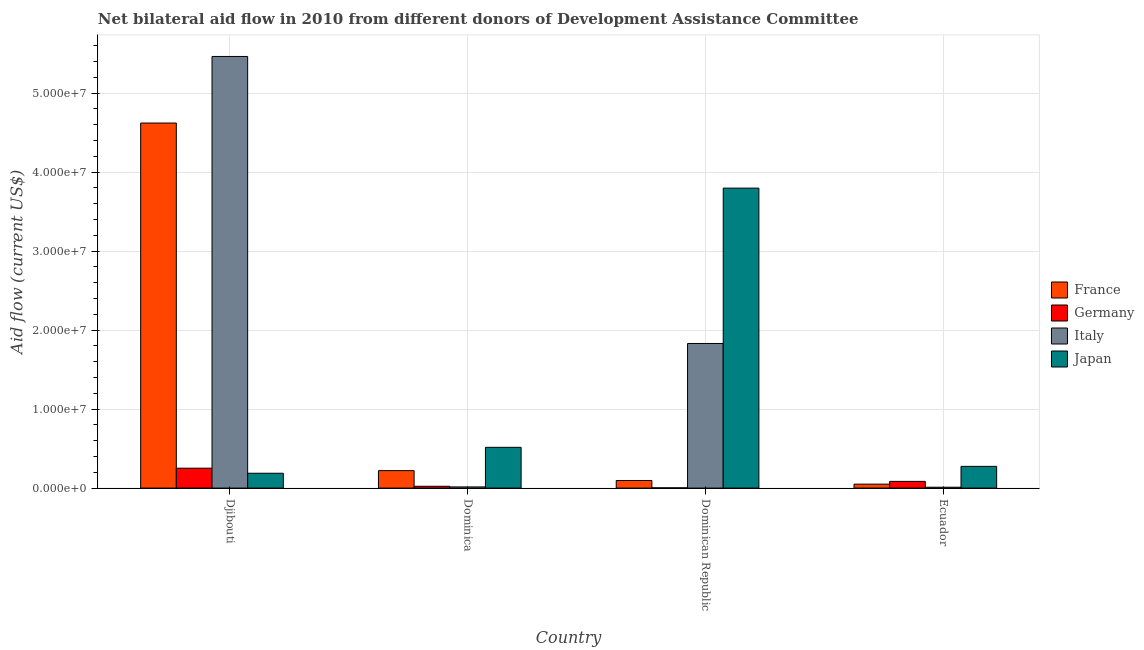Are the number of bars on each tick of the X-axis equal?
Your answer should be very brief. Yes. What is the label of the 4th group of bars from the left?
Ensure brevity in your answer.  Ecuador. What is the amount of aid given by france in Djibouti?
Your answer should be very brief. 4.62e+07. Across all countries, what is the maximum amount of aid given by japan?
Your answer should be compact. 3.80e+07. Across all countries, what is the minimum amount of aid given by france?
Provide a succinct answer. 5.00e+05. In which country was the amount of aid given by france maximum?
Provide a short and direct response. Djibouti. In which country was the amount of aid given by france minimum?
Keep it short and to the point. Ecuador. What is the total amount of aid given by japan in the graph?
Provide a succinct answer. 4.78e+07. What is the difference between the amount of aid given by france in Dominica and that in Ecuador?
Provide a succinct answer. 1.71e+06. What is the difference between the amount of aid given by germany in Ecuador and the amount of aid given by italy in Dominican Republic?
Keep it short and to the point. -1.75e+07. What is the average amount of aid given by germany per country?
Give a very brief answer. 9.08e+05. What is the difference between the amount of aid given by germany and amount of aid given by france in Djibouti?
Offer a very short reply. -4.37e+07. What is the ratio of the amount of aid given by italy in Djibouti to that in Ecuador?
Your answer should be very brief. 496.82. Is the amount of aid given by italy in Dominican Republic less than that in Ecuador?
Your answer should be very brief. No. What is the difference between the highest and the second highest amount of aid given by japan?
Your answer should be compact. 3.28e+07. What is the difference between the highest and the lowest amount of aid given by france?
Make the answer very short. 4.57e+07. In how many countries, is the amount of aid given by france greater than the average amount of aid given by france taken over all countries?
Keep it short and to the point. 1. Is the sum of the amount of aid given by japan in Dominican Republic and Ecuador greater than the maximum amount of aid given by italy across all countries?
Keep it short and to the point. No. Is it the case that in every country, the sum of the amount of aid given by japan and amount of aid given by france is greater than the sum of amount of aid given by germany and amount of aid given by italy?
Provide a succinct answer. Yes. What does the 1st bar from the left in Dominica represents?
Give a very brief answer. France. Is it the case that in every country, the sum of the amount of aid given by france and amount of aid given by germany is greater than the amount of aid given by italy?
Provide a short and direct response. No. How many bars are there?
Ensure brevity in your answer.  16. How many countries are there in the graph?
Provide a succinct answer. 4. What is the difference between two consecutive major ticks on the Y-axis?
Give a very brief answer. 1.00e+07. Where does the legend appear in the graph?
Ensure brevity in your answer.  Center right. How many legend labels are there?
Offer a very short reply. 4. How are the legend labels stacked?
Offer a terse response. Vertical. What is the title of the graph?
Keep it short and to the point. Net bilateral aid flow in 2010 from different donors of Development Assistance Committee. Does "United States" appear as one of the legend labels in the graph?
Your response must be concise. No. What is the label or title of the Y-axis?
Keep it short and to the point. Aid flow (current US$). What is the Aid flow (current US$) of France in Djibouti?
Offer a terse response. 4.62e+07. What is the Aid flow (current US$) of Germany in Djibouti?
Give a very brief answer. 2.52e+06. What is the Aid flow (current US$) in Italy in Djibouti?
Provide a succinct answer. 5.46e+07. What is the Aid flow (current US$) in Japan in Djibouti?
Keep it short and to the point. 1.88e+06. What is the Aid flow (current US$) in France in Dominica?
Make the answer very short. 2.21e+06. What is the Aid flow (current US$) in Germany in Dominica?
Keep it short and to the point. 2.30e+05. What is the Aid flow (current US$) of Japan in Dominica?
Your answer should be very brief. 5.16e+06. What is the Aid flow (current US$) in France in Dominican Republic?
Your answer should be very brief. 9.60e+05. What is the Aid flow (current US$) in Germany in Dominican Republic?
Make the answer very short. 3.00e+04. What is the Aid flow (current US$) of Italy in Dominican Republic?
Your answer should be compact. 1.83e+07. What is the Aid flow (current US$) in Japan in Dominican Republic?
Your response must be concise. 3.80e+07. What is the Aid flow (current US$) of France in Ecuador?
Your response must be concise. 5.00e+05. What is the Aid flow (current US$) of Germany in Ecuador?
Your answer should be very brief. 8.50e+05. What is the Aid flow (current US$) of Italy in Ecuador?
Your answer should be very brief. 1.10e+05. What is the Aid flow (current US$) of Japan in Ecuador?
Offer a terse response. 2.75e+06. Across all countries, what is the maximum Aid flow (current US$) in France?
Your answer should be compact. 4.62e+07. Across all countries, what is the maximum Aid flow (current US$) in Germany?
Your answer should be very brief. 2.52e+06. Across all countries, what is the maximum Aid flow (current US$) in Italy?
Offer a terse response. 5.46e+07. Across all countries, what is the maximum Aid flow (current US$) in Japan?
Give a very brief answer. 3.80e+07. Across all countries, what is the minimum Aid flow (current US$) in France?
Offer a terse response. 5.00e+05. Across all countries, what is the minimum Aid flow (current US$) of Japan?
Your answer should be very brief. 1.88e+06. What is the total Aid flow (current US$) of France in the graph?
Make the answer very short. 4.99e+07. What is the total Aid flow (current US$) of Germany in the graph?
Provide a short and direct response. 3.63e+06. What is the total Aid flow (current US$) of Italy in the graph?
Your answer should be very brief. 7.32e+07. What is the total Aid flow (current US$) in Japan in the graph?
Offer a very short reply. 4.78e+07. What is the difference between the Aid flow (current US$) of France in Djibouti and that in Dominica?
Provide a short and direct response. 4.40e+07. What is the difference between the Aid flow (current US$) of Germany in Djibouti and that in Dominica?
Your answer should be very brief. 2.29e+06. What is the difference between the Aid flow (current US$) in Italy in Djibouti and that in Dominica?
Keep it short and to the point. 5.45e+07. What is the difference between the Aid flow (current US$) in Japan in Djibouti and that in Dominica?
Your answer should be compact. -3.28e+06. What is the difference between the Aid flow (current US$) of France in Djibouti and that in Dominican Republic?
Provide a short and direct response. 4.53e+07. What is the difference between the Aid flow (current US$) in Germany in Djibouti and that in Dominican Republic?
Give a very brief answer. 2.49e+06. What is the difference between the Aid flow (current US$) in Italy in Djibouti and that in Dominican Republic?
Provide a succinct answer. 3.63e+07. What is the difference between the Aid flow (current US$) of Japan in Djibouti and that in Dominican Republic?
Your response must be concise. -3.61e+07. What is the difference between the Aid flow (current US$) of France in Djibouti and that in Ecuador?
Your answer should be very brief. 4.57e+07. What is the difference between the Aid flow (current US$) in Germany in Djibouti and that in Ecuador?
Offer a very short reply. 1.67e+06. What is the difference between the Aid flow (current US$) of Italy in Djibouti and that in Ecuador?
Make the answer very short. 5.45e+07. What is the difference between the Aid flow (current US$) of Japan in Djibouti and that in Ecuador?
Your answer should be compact. -8.70e+05. What is the difference between the Aid flow (current US$) of France in Dominica and that in Dominican Republic?
Your answer should be compact. 1.25e+06. What is the difference between the Aid flow (current US$) of Italy in Dominica and that in Dominican Republic?
Ensure brevity in your answer.  -1.82e+07. What is the difference between the Aid flow (current US$) of Japan in Dominica and that in Dominican Republic?
Make the answer very short. -3.28e+07. What is the difference between the Aid flow (current US$) in France in Dominica and that in Ecuador?
Offer a very short reply. 1.71e+06. What is the difference between the Aid flow (current US$) in Germany in Dominica and that in Ecuador?
Make the answer very short. -6.20e+05. What is the difference between the Aid flow (current US$) of Italy in Dominica and that in Ecuador?
Keep it short and to the point. 4.00e+04. What is the difference between the Aid flow (current US$) of Japan in Dominica and that in Ecuador?
Your response must be concise. 2.41e+06. What is the difference between the Aid flow (current US$) in France in Dominican Republic and that in Ecuador?
Offer a very short reply. 4.60e+05. What is the difference between the Aid flow (current US$) in Germany in Dominican Republic and that in Ecuador?
Ensure brevity in your answer.  -8.20e+05. What is the difference between the Aid flow (current US$) in Italy in Dominican Republic and that in Ecuador?
Give a very brief answer. 1.82e+07. What is the difference between the Aid flow (current US$) of Japan in Dominican Republic and that in Ecuador?
Your answer should be very brief. 3.52e+07. What is the difference between the Aid flow (current US$) in France in Djibouti and the Aid flow (current US$) in Germany in Dominica?
Offer a terse response. 4.60e+07. What is the difference between the Aid flow (current US$) of France in Djibouti and the Aid flow (current US$) of Italy in Dominica?
Keep it short and to the point. 4.61e+07. What is the difference between the Aid flow (current US$) in France in Djibouti and the Aid flow (current US$) in Japan in Dominica?
Offer a terse response. 4.11e+07. What is the difference between the Aid flow (current US$) in Germany in Djibouti and the Aid flow (current US$) in Italy in Dominica?
Give a very brief answer. 2.37e+06. What is the difference between the Aid flow (current US$) in Germany in Djibouti and the Aid flow (current US$) in Japan in Dominica?
Your response must be concise. -2.64e+06. What is the difference between the Aid flow (current US$) in Italy in Djibouti and the Aid flow (current US$) in Japan in Dominica?
Offer a terse response. 4.95e+07. What is the difference between the Aid flow (current US$) of France in Djibouti and the Aid flow (current US$) of Germany in Dominican Republic?
Provide a succinct answer. 4.62e+07. What is the difference between the Aid flow (current US$) of France in Djibouti and the Aid flow (current US$) of Italy in Dominican Republic?
Provide a succinct answer. 2.79e+07. What is the difference between the Aid flow (current US$) of France in Djibouti and the Aid flow (current US$) of Japan in Dominican Republic?
Ensure brevity in your answer.  8.24e+06. What is the difference between the Aid flow (current US$) of Germany in Djibouti and the Aid flow (current US$) of Italy in Dominican Republic?
Your answer should be very brief. -1.58e+07. What is the difference between the Aid flow (current US$) in Germany in Djibouti and the Aid flow (current US$) in Japan in Dominican Republic?
Your answer should be very brief. -3.55e+07. What is the difference between the Aid flow (current US$) in Italy in Djibouti and the Aid flow (current US$) in Japan in Dominican Republic?
Provide a short and direct response. 1.67e+07. What is the difference between the Aid flow (current US$) in France in Djibouti and the Aid flow (current US$) in Germany in Ecuador?
Provide a short and direct response. 4.54e+07. What is the difference between the Aid flow (current US$) in France in Djibouti and the Aid flow (current US$) in Italy in Ecuador?
Keep it short and to the point. 4.61e+07. What is the difference between the Aid flow (current US$) of France in Djibouti and the Aid flow (current US$) of Japan in Ecuador?
Your answer should be compact. 4.35e+07. What is the difference between the Aid flow (current US$) of Germany in Djibouti and the Aid flow (current US$) of Italy in Ecuador?
Provide a succinct answer. 2.41e+06. What is the difference between the Aid flow (current US$) of Germany in Djibouti and the Aid flow (current US$) of Japan in Ecuador?
Ensure brevity in your answer.  -2.30e+05. What is the difference between the Aid flow (current US$) in Italy in Djibouti and the Aid flow (current US$) in Japan in Ecuador?
Your answer should be very brief. 5.19e+07. What is the difference between the Aid flow (current US$) of France in Dominica and the Aid flow (current US$) of Germany in Dominican Republic?
Your answer should be compact. 2.18e+06. What is the difference between the Aid flow (current US$) in France in Dominica and the Aid flow (current US$) in Italy in Dominican Republic?
Offer a terse response. -1.61e+07. What is the difference between the Aid flow (current US$) of France in Dominica and the Aid flow (current US$) of Japan in Dominican Republic?
Provide a succinct answer. -3.58e+07. What is the difference between the Aid flow (current US$) of Germany in Dominica and the Aid flow (current US$) of Italy in Dominican Republic?
Keep it short and to the point. -1.81e+07. What is the difference between the Aid flow (current US$) of Germany in Dominica and the Aid flow (current US$) of Japan in Dominican Republic?
Your answer should be compact. -3.78e+07. What is the difference between the Aid flow (current US$) in Italy in Dominica and the Aid flow (current US$) in Japan in Dominican Republic?
Provide a succinct answer. -3.78e+07. What is the difference between the Aid flow (current US$) in France in Dominica and the Aid flow (current US$) in Germany in Ecuador?
Provide a short and direct response. 1.36e+06. What is the difference between the Aid flow (current US$) of France in Dominica and the Aid flow (current US$) of Italy in Ecuador?
Provide a short and direct response. 2.10e+06. What is the difference between the Aid flow (current US$) in France in Dominica and the Aid flow (current US$) in Japan in Ecuador?
Give a very brief answer. -5.40e+05. What is the difference between the Aid flow (current US$) in Germany in Dominica and the Aid flow (current US$) in Japan in Ecuador?
Make the answer very short. -2.52e+06. What is the difference between the Aid flow (current US$) in Italy in Dominica and the Aid flow (current US$) in Japan in Ecuador?
Your answer should be very brief. -2.60e+06. What is the difference between the Aid flow (current US$) of France in Dominican Republic and the Aid flow (current US$) of Italy in Ecuador?
Ensure brevity in your answer.  8.50e+05. What is the difference between the Aid flow (current US$) in France in Dominican Republic and the Aid flow (current US$) in Japan in Ecuador?
Ensure brevity in your answer.  -1.79e+06. What is the difference between the Aid flow (current US$) in Germany in Dominican Republic and the Aid flow (current US$) in Italy in Ecuador?
Offer a very short reply. -8.00e+04. What is the difference between the Aid flow (current US$) of Germany in Dominican Republic and the Aid flow (current US$) of Japan in Ecuador?
Offer a very short reply. -2.72e+06. What is the difference between the Aid flow (current US$) of Italy in Dominican Republic and the Aid flow (current US$) of Japan in Ecuador?
Offer a very short reply. 1.56e+07. What is the average Aid flow (current US$) of France per country?
Your answer should be compact. 1.25e+07. What is the average Aid flow (current US$) in Germany per country?
Make the answer very short. 9.08e+05. What is the average Aid flow (current US$) of Italy per country?
Make the answer very short. 1.83e+07. What is the average Aid flow (current US$) in Japan per country?
Keep it short and to the point. 1.19e+07. What is the difference between the Aid flow (current US$) in France and Aid flow (current US$) in Germany in Djibouti?
Offer a terse response. 4.37e+07. What is the difference between the Aid flow (current US$) in France and Aid flow (current US$) in Italy in Djibouti?
Ensure brevity in your answer.  -8.43e+06. What is the difference between the Aid flow (current US$) in France and Aid flow (current US$) in Japan in Djibouti?
Provide a short and direct response. 4.43e+07. What is the difference between the Aid flow (current US$) in Germany and Aid flow (current US$) in Italy in Djibouti?
Provide a short and direct response. -5.21e+07. What is the difference between the Aid flow (current US$) of Germany and Aid flow (current US$) of Japan in Djibouti?
Your answer should be compact. 6.40e+05. What is the difference between the Aid flow (current US$) of Italy and Aid flow (current US$) of Japan in Djibouti?
Make the answer very short. 5.28e+07. What is the difference between the Aid flow (current US$) in France and Aid flow (current US$) in Germany in Dominica?
Provide a succinct answer. 1.98e+06. What is the difference between the Aid flow (current US$) in France and Aid flow (current US$) in Italy in Dominica?
Your response must be concise. 2.06e+06. What is the difference between the Aid flow (current US$) in France and Aid flow (current US$) in Japan in Dominica?
Keep it short and to the point. -2.95e+06. What is the difference between the Aid flow (current US$) of Germany and Aid flow (current US$) of Japan in Dominica?
Give a very brief answer. -4.93e+06. What is the difference between the Aid flow (current US$) in Italy and Aid flow (current US$) in Japan in Dominica?
Offer a terse response. -5.01e+06. What is the difference between the Aid flow (current US$) of France and Aid flow (current US$) of Germany in Dominican Republic?
Ensure brevity in your answer.  9.30e+05. What is the difference between the Aid flow (current US$) in France and Aid flow (current US$) in Italy in Dominican Republic?
Provide a succinct answer. -1.74e+07. What is the difference between the Aid flow (current US$) in France and Aid flow (current US$) in Japan in Dominican Republic?
Provide a short and direct response. -3.70e+07. What is the difference between the Aid flow (current US$) of Germany and Aid flow (current US$) of Italy in Dominican Republic?
Offer a terse response. -1.83e+07. What is the difference between the Aid flow (current US$) of Germany and Aid flow (current US$) of Japan in Dominican Republic?
Ensure brevity in your answer.  -3.80e+07. What is the difference between the Aid flow (current US$) of Italy and Aid flow (current US$) of Japan in Dominican Republic?
Offer a terse response. -1.97e+07. What is the difference between the Aid flow (current US$) in France and Aid flow (current US$) in Germany in Ecuador?
Make the answer very short. -3.50e+05. What is the difference between the Aid flow (current US$) in France and Aid flow (current US$) in Japan in Ecuador?
Provide a succinct answer. -2.25e+06. What is the difference between the Aid flow (current US$) in Germany and Aid flow (current US$) in Italy in Ecuador?
Offer a very short reply. 7.40e+05. What is the difference between the Aid flow (current US$) of Germany and Aid flow (current US$) of Japan in Ecuador?
Keep it short and to the point. -1.90e+06. What is the difference between the Aid flow (current US$) in Italy and Aid flow (current US$) in Japan in Ecuador?
Your answer should be compact. -2.64e+06. What is the ratio of the Aid flow (current US$) of France in Djibouti to that in Dominica?
Offer a very short reply. 20.91. What is the ratio of the Aid flow (current US$) in Germany in Djibouti to that in Dominica?
Ensure brevity in your answer.  10.96. What is the ratio of the Aid flow (current US$) of Italy in Djibouti to that in Dominica?
Your response must be concise. 364.33. What is the ratio of the Aid flow (current US$) of Japan in Djibouti to that in Dominica?
Ensure brevity in your answer.  0.36. What is the ratio of the Aid flow (current US$) of France in Djibouti to that in Dominican Republic?
Keep it short and to the point. 48.15. What is the ratio of the Aid flow (current US$) of Italy in Djibouti to that in Dominican Republic?
Your answer should be compact. 2.98. What is the ratio of the Aid flow (current US$) of Japan in Djibouti to that in Dominican Republic?
Your answer should be very brief. 0.05. What is the ratio of the Aid flow (current US$) in France in Djibouti to that in Ecuador?
Give a very brief answer. 92.44. What is the ratio of the Aid flow (current US$) in Germany in Djibouti to that in Ecuador?
Provide a short and direct response. 2.96. What is the ratio of the Aid flow (current US$) in Italy in Djibouti to that in Ecuador?
Provide a succinct answer. 496.82. What is the ratio of the Aid flow (current US$) in Japan in Djibouti to that in Ecuador?
Ensure brevity in your answer.  0.68. What is the ratio of the Aid flow (current US$) of France in Dominica to that in Dominican Republic?
Ensure brevity in your answer.  2.3. What is the ratio of the Aid flow (current US$) of Germany in Dominica to that in Dominican Republic?
Give a very brief answer. 7.67. What is the ratio of the Aid flow (current US$) of Italy in Dominica to that in Dominican Republic?
Keep it short and to the point. 0.01. What is the ratio of the Aid flow (current US$) of Japan in Dominica to that in Dominican Republic?
Your response must be concise. 0.14. What is the ratio of the Aid flow (current US$) in France in Dominica to that in Ecuador?
Offer a very short reply. 4.42. What is the ratio of the Aid flow (current US$) in Germany in Dominica to that in Ecuador?
Provide a short and direct response. 0.27. What is the ratio of the Aid flow (current US$) of Italy in Dominica to that in Ecuador?
Provide a short and direct response. 1.36. What is the ratio of the Aid flow (current US$) of Japan in Dominica to that in Ecuador?
Keep it short and to the point. 1.88. What is the ratio of the Aid flow (current US$) in France in Dominican Republic to that in Ecuador?
Ensure brevity in your answer.  1.92. What is the ratio of the Aid flow (current US$) in Germany in Dominican Republic to that in Ecuador?
Keep it short and to the point. 0.04. What is the ratio of the Aid flow (current US$) in Italy in Dominican Republic to that in Ecuador?
Offer a very short reply. 166.45. What is the ratio of the Aid flow (current US$) in Japan in Dominican Republic to that in Ecuador?
Ensure brevity in your answer.  13.81. What is the difference between the highest and the second highest Aid flow (current US$) in France?
Provide a short and direct response. 4.40e+07. What is the difference between the highest and the second highest Aid flow (current US$) of Germany?
Provide a short and direct response. 1.67e+06. What is the difference between the highest and the second highest Aid flow (current US$) of Italy?
Your response must be concise. 3.63e+07. What is the difference between the highest and the second highest Aid flow (current US$) in Japan?
Your response must be concise. 3.28e+07. What is the difference between the highest and the lowest Aid flow (current US$) in France?
Keep it short and to the point. 4.57e+07. What is the difference between the highest and the lowest Aid flow (current US$) in Germany?
Provide a short and direct response. 2.49e+06. What is the difference between the highest and the lowest Aid flow (current US$) of Italy?
Offer a very short reply. 5.45e+07. What is the difference between the highest and the lowest Aid flow (current US$) of Japan?
Offer a very short reply. 3.61e+07. 